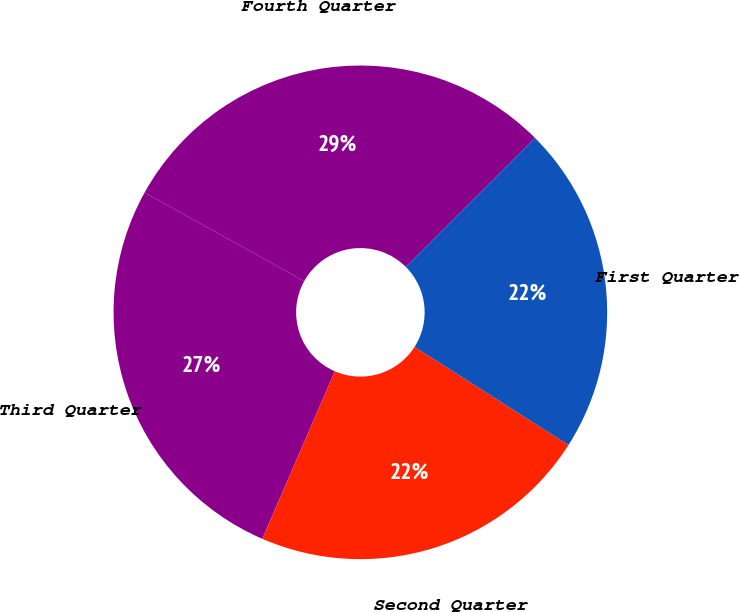Convert chart to OTSL. <chart><loc_0><loc_0><loc_500><loc_500><pie_chart><fcel>Fourth Quarter<fcel>Third Quarter<fcel>Second Quarter<fcel>First Quarter<nl><fcel>29.44%<fcel>26.56%<fcel>22.47%<fcel>21.53%<nl></chart> 